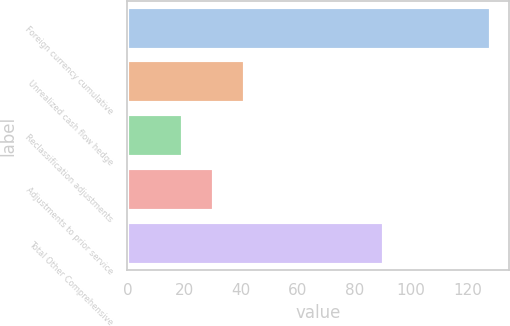<chart> <loc_0><loc_0><loc_500><loc_500><bar_chart><fcel>Foreign currency cumulative<fcel>Unrealized cash flow hedge<fcel>Reclassification adjustments<fcel>Adjustments to prior service<fcel>Total Other Comprehensive<nl><fcel>128.2<fcel>41.32<fcel>19.6<fcel>30.46<fcel>90.3<nl></chart> 